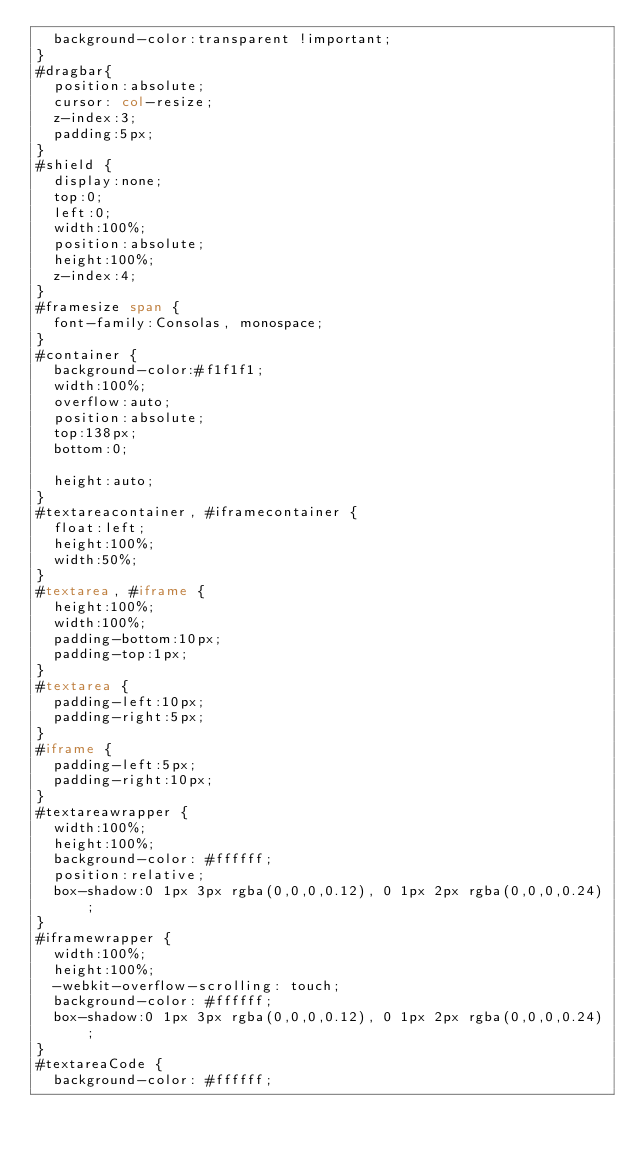<code> <loc_0><loc_0><loc_500><loc_500><_HTML_>  background-color:transparent !important;
}
#dragbar{
  position:absolute;
  cursor: col-resize;
  z-index:3;
  padding:5px;
}
#shield {
  display:none;
  top:0;
  left:0;
  width:100%;
  position:absolute;
  height:100%;
  z-index:4;
}
#framesize span {
  font-family:Consolas, monospace;
}
#container {
  background-color:#f1f1f1;
  width:100%;
  overflow:auto;
  position:absolute;
  top:138px;
  bottom:0;

  height:auto;
}
#textareacontainer, #iframecontainer {
  float:left;
  height:100%;
  width:50%;
}
#textarea, #iframe {
  height:100%;
  width:100%;
  padding-bottom:10px;
  padding-top:1px;
}
#textarea {
  padding-left:10px;
  padding-right:5px;  
}
#iframe {
  padding-left:5px;
  padding-right:10px;  
}
#textareawrapper {
  width:100%;
  height:100%;
  background-color: #ffffff;
  position:relative;
  box-shadow:0 1px 3px rgba(0,0,0,0.12), 0 1px 2px rgba(0,0,0,0.24);
}
#iframewrapper {
  width:100%;
  height:100%;
  -webkit-overflow-scrolling: touch;
  background-color: #ffffff;
  box-shadow:0 1px 3px rgba(0,0,0,0.12), 0 1px 2px rgba(0,0,0,0.24);
}
#textareaCode {
  background-color: #ffffff;</code> 